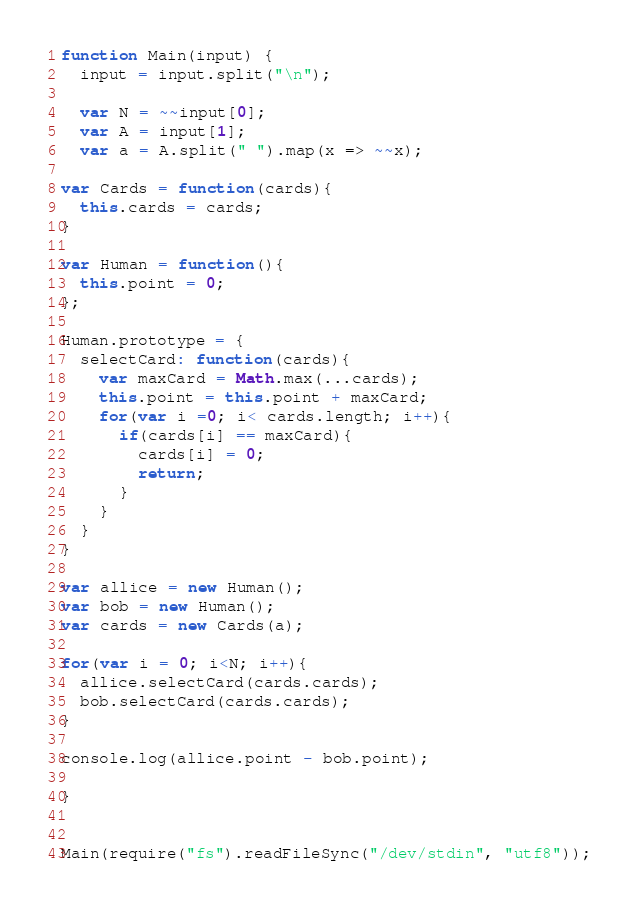<code> <loc_0><loc_0><loc_500><loc_500><_JavaScript_>function Main(input) {
  input = input.split("\n");

  var N = ~~input[0];
  var A = input[1];
  var a = A.split(" ").map(x => ~~x);

var Cards = function(cards){
  this.cards = cards;
}

var Human = function(){
  this.point = 0;
};

Human.prototype = {
  selectCard: function(cards){
    var maxCard = Math.max(...cards);
    this.point = this.point + maxCard;
    for(var i =0; i< cards.length; i++){
      if(cards[i] == maxCard){
        cards[i] = 0;
        return;
      }
    }
  }
}

var allice = new Human();
var bob = new Human();
var cards = new Cards(a);

for(var i = 0; i<N; i++){
  allice.selectCard(cards.cards);
  bob.selectCard(cards.cards);
}

console.log(allice.point - bob.point);

}


Main(require("fs").readFileSync("/dev/stdin", "utf8"));
</code> 